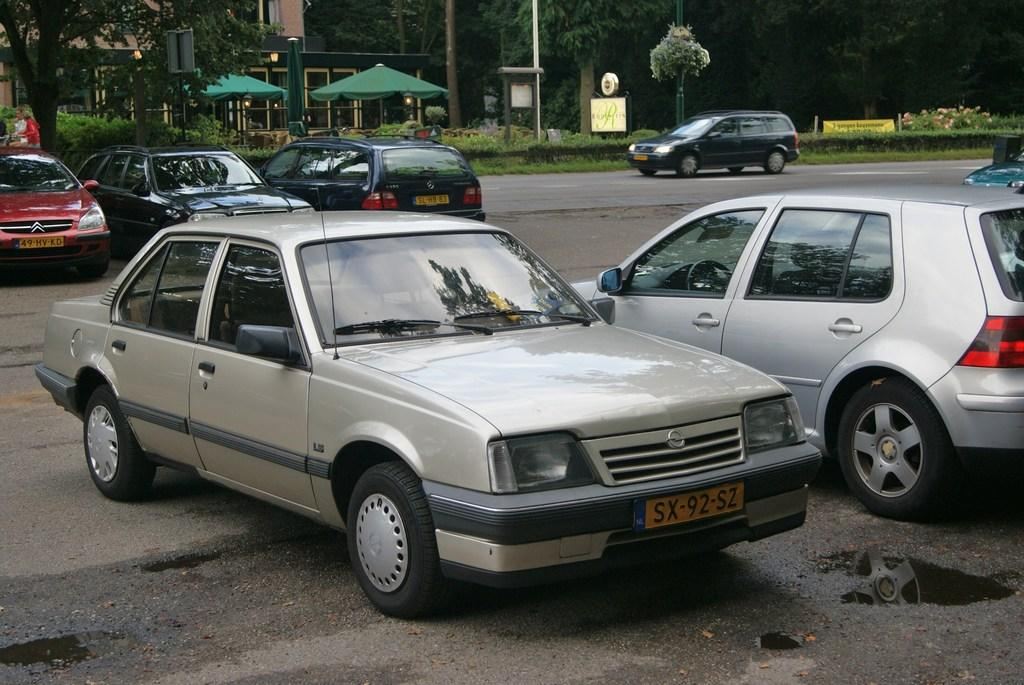What is the main feature of the image? There is a road in the image. What else can be seen on the road? There are vehicles present in the image. What type of natural elements are visible in the image? There are trees in the image. What objects might be used for protection from the elements? There are umbrellas present in the image. What type of structure is visible in the image? There is a building in the image. Can you see a seashore in the image? No, there is no seashore present in the image. Is there a volcano visible in the image? No, there is no volcano present in the image. 